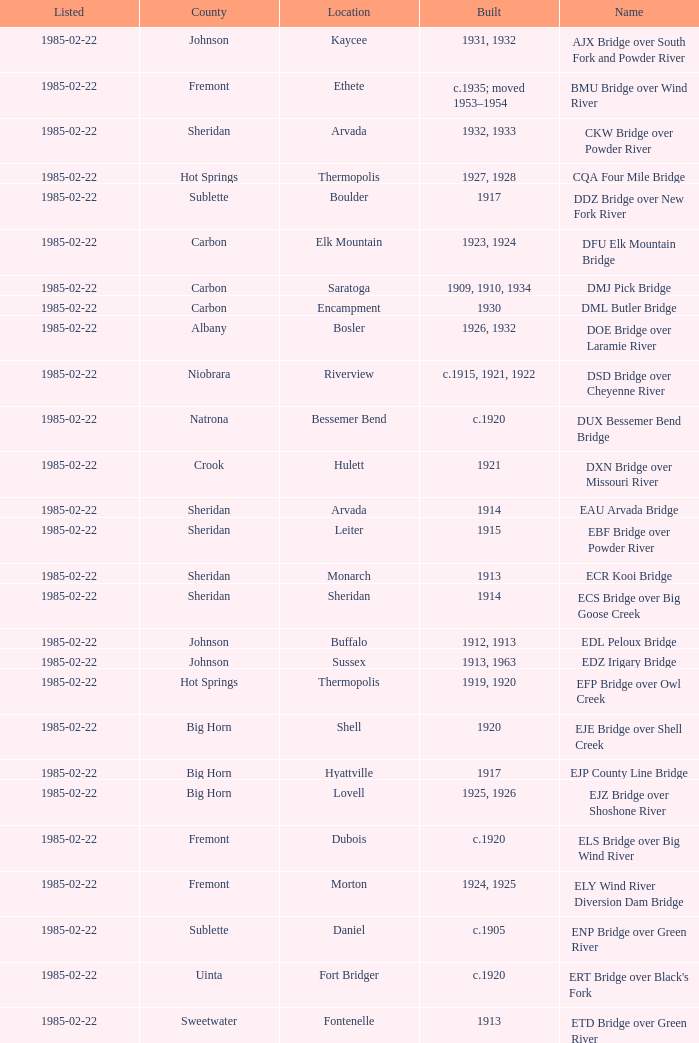What bridge in Sheridan county was built in 1915? EBF Bridge over Powder River. 